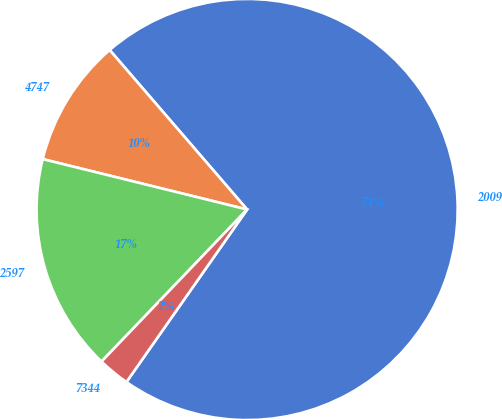Convert chart to OTSL. <chart><loc_0><loc_0><loc_500><loc_500><pie_chart><fcel>2009<fcel>4747<fcel>2597<fcel>7344<nl><fcel>71.03%<fcel>9.83%<fcel>16.69%<fcel>2.44%<nl></chart> 